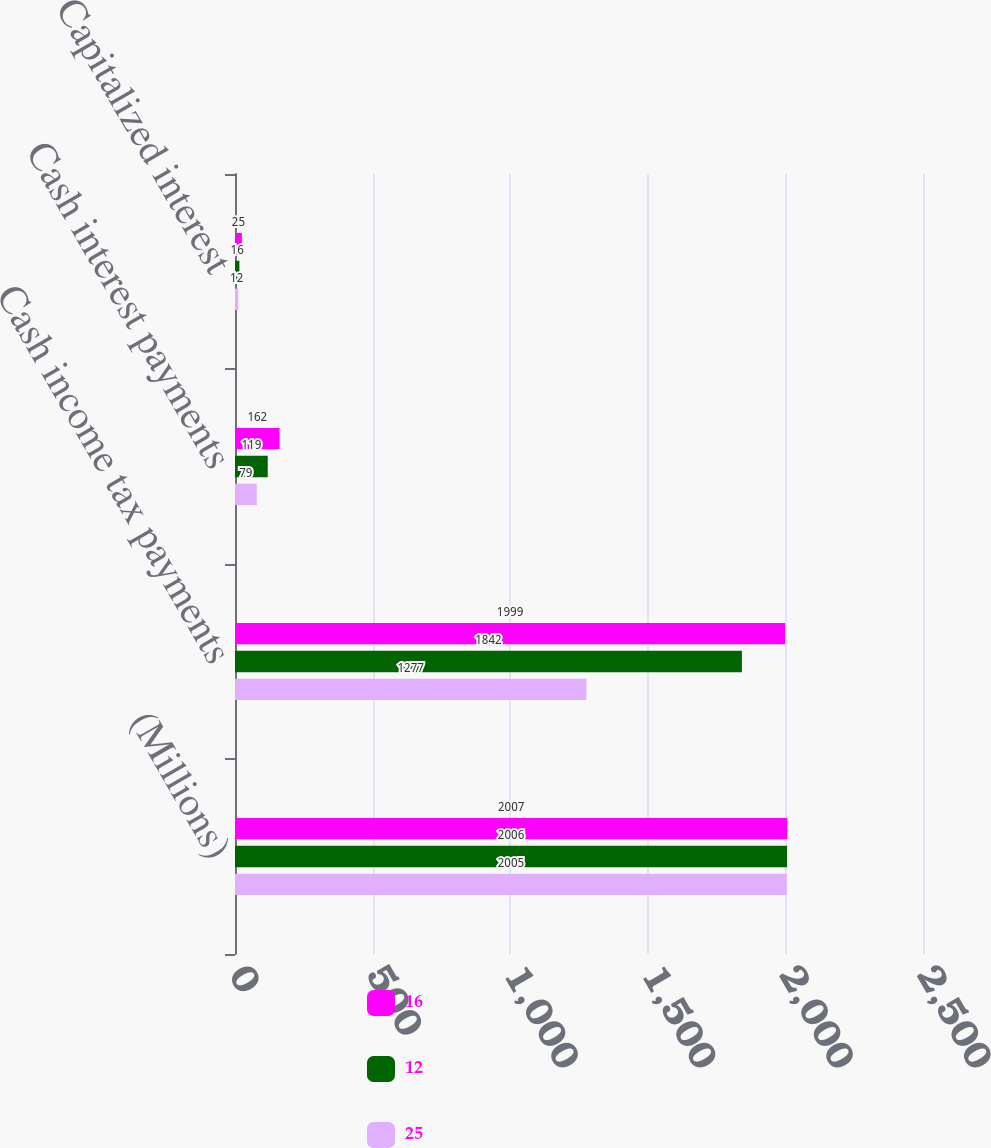Convert chart. <chart><loc_0><loc_0><loc_500><loc_500><stacked_bar_chart><ecel><fcel>(Millions)<fcel>Cash income tax payments<fcel>Cash interest payments<fcel>Capitalized interest<nl><fcel>16<fcel>2007<fcel>1999<fcel>162<fcel>25<nl><fcel>12<fcel>2006<fcel>1842<fcel>119<fcel>16<nl><fcel>25<fcel>2005<fcel>1277<fcel>79<fcel>12<nl></chart> 